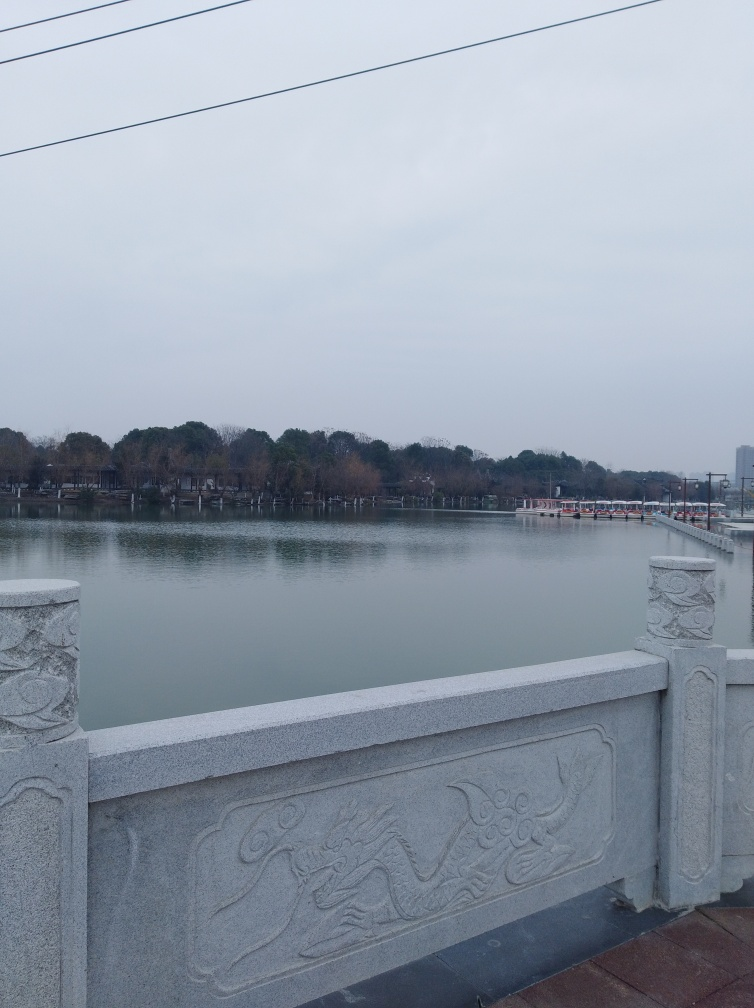How does the image make you feel and what mood does it evoke? The image evokes a tranquil and serene mood, likely due to the still waters and the soft, diffused lighting. The muted colors and overcast sky might also prompt feelings of introspection or solemnity. It's a scene that invites quiet contemplation. 